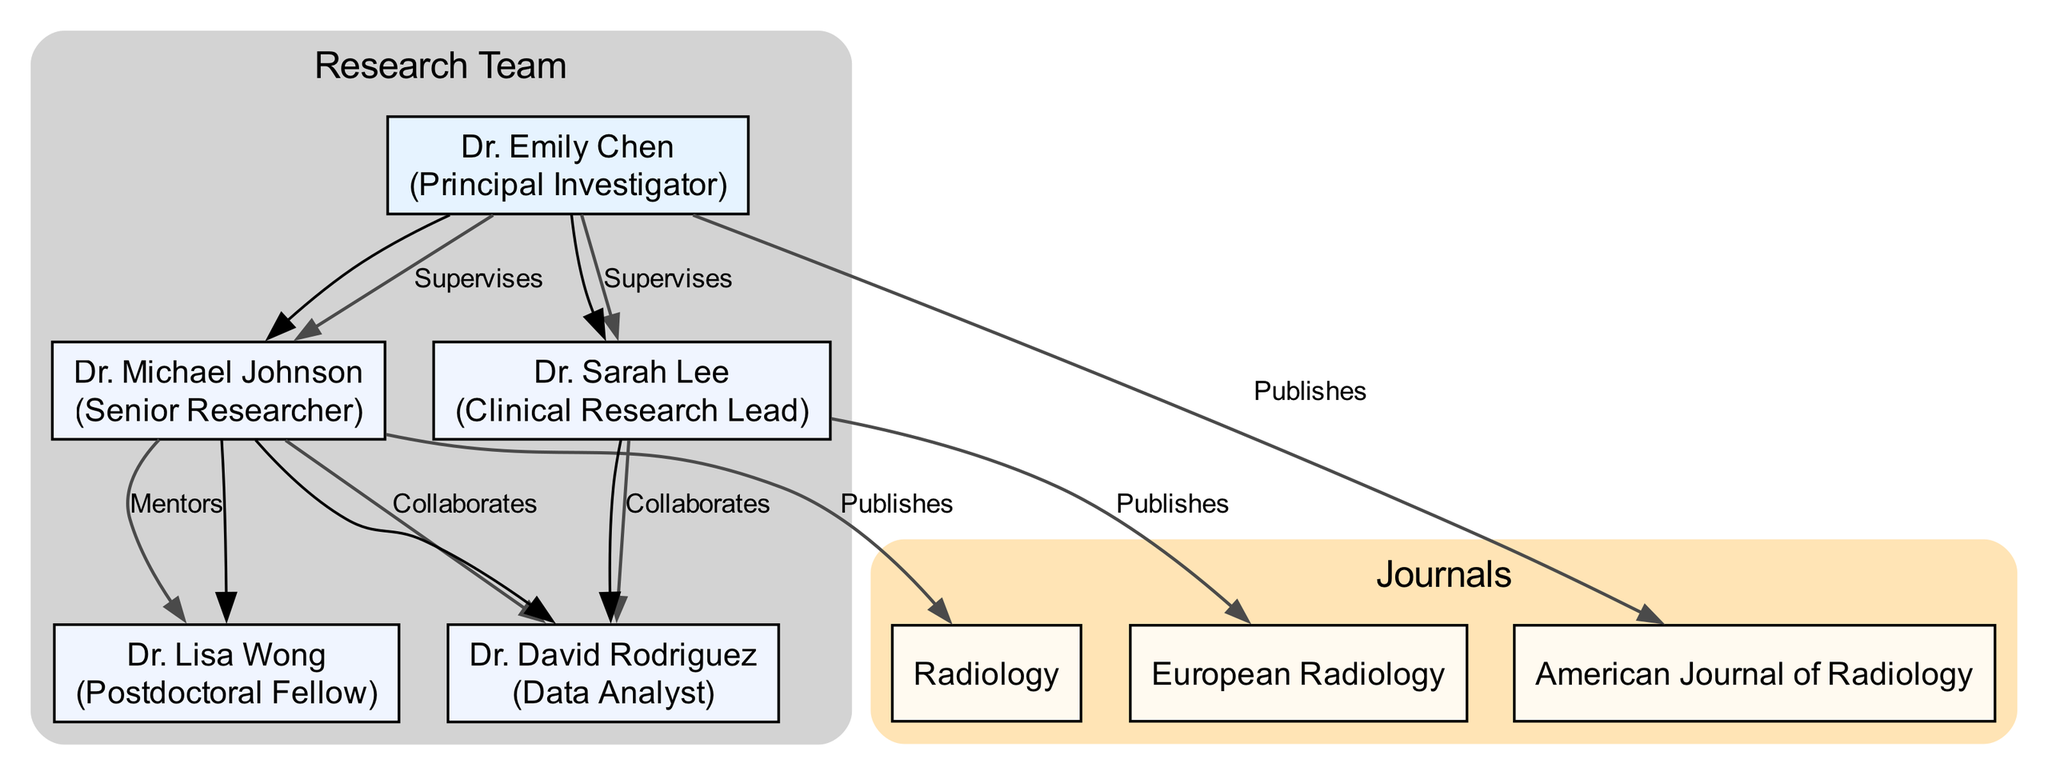What is the role of Dr. Emily Chen? By examining the node representing Dr. Emily Chen, it clearly states her role as "Principal Investigator."
Answer: Principal Investigator How many publications are attributed to Dr. Sarah Lee? Looking at the edges connected to Dr. Sarah Lee, there is a single edge labeled "Publishes" that connects her to "European Radiology," indicating one publication.
Answer: 1 Which team member supervises Dr. Michael Johnson? The edge from Dr. Emily Chen to Dr. Michael Johnson is labeled "Supervises," indicating that Dr. Emily Chen is the supervisor for Dr. Michael Johnson.
Answer: Dr. Emily Chen How many collaborations does Dr. Michael Johnson have? Analyzing the edges from Dr. Michael Johnson, there are two edges leading to Dr. David Rodriguez and Dr. Lisa Wong, which indicates two collaborations.
Answer: 2 What is the relationship between Dr. Sarah Lee and Dr. David Rodriguez? The edge connecting Dr. Sarah Lee to Dr. David Rodriguez is labeled "Collaborates," indicating their collaborative relationship.
Answer: Collaborates Which journal is associated with Dr. Emily Chen's publications? The edge from Dr. Emily Chen to the "American Journal of Radiology" is labeled "Publishes," confirming her publication in that journal.
Answer: American Journal of Radiology Which role has mentorship responsibilities in the research team? By checking the edges leading from Dr. Michael Johnson, one labeled "Mentors" connects him to Dr. Lisa Wong, indicating his mentorship role.
Answer: Dr. Michael Johnson How many nodes represent team members in total? Counting the nodes listed, there are five representing team members: Dr. Emily Chen, Dr. Michael Johnson, Dr. Sarah Lee, Dr. David Rodriguez, and Dr. Lisa Wong.
Answer: 5 Which publication is connected to the Clinical Research Lead? The edge from Dr. Sarah Lee leads to "European Radiology" and is labeled "Publishes," linking the Clinical Research Lead to that publication.
Answer: European Radiology 